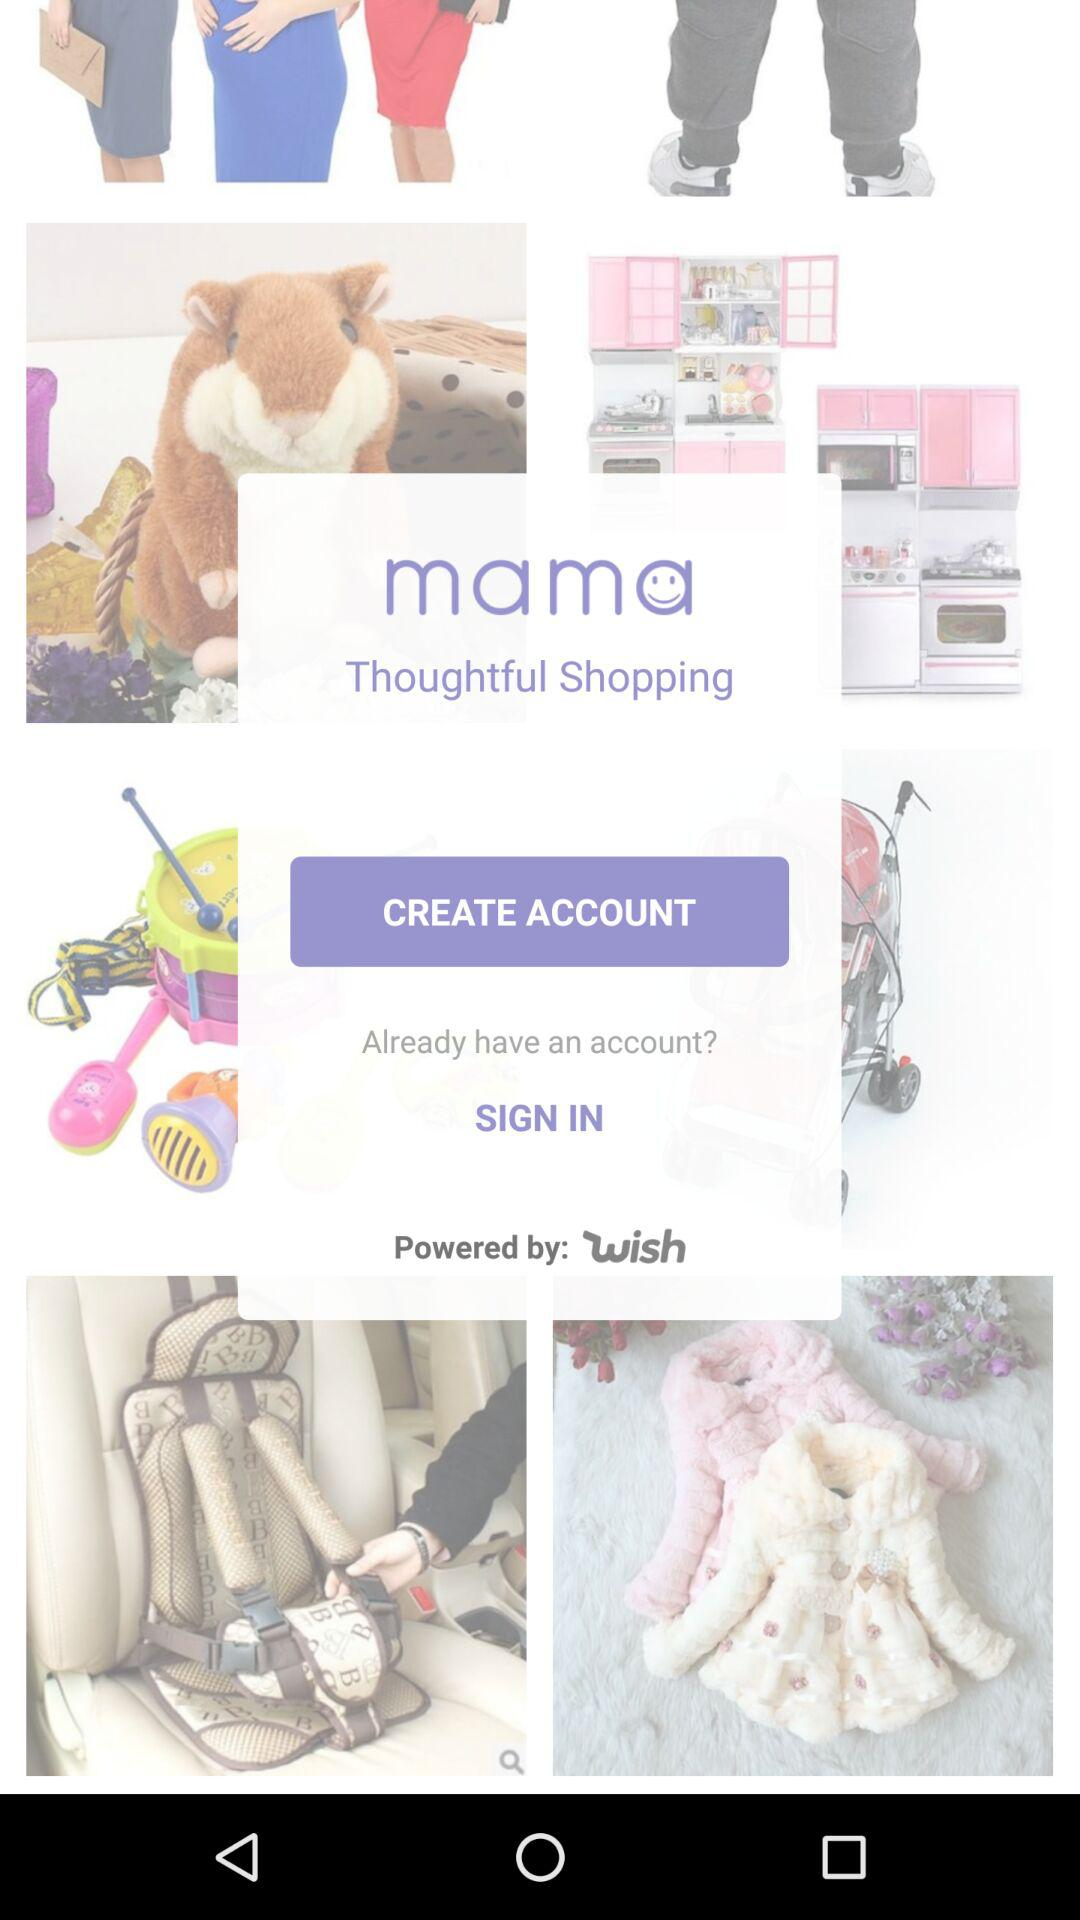What is the account name?
When the provided information is insufficient, respond with <no answer>. <no answer> 